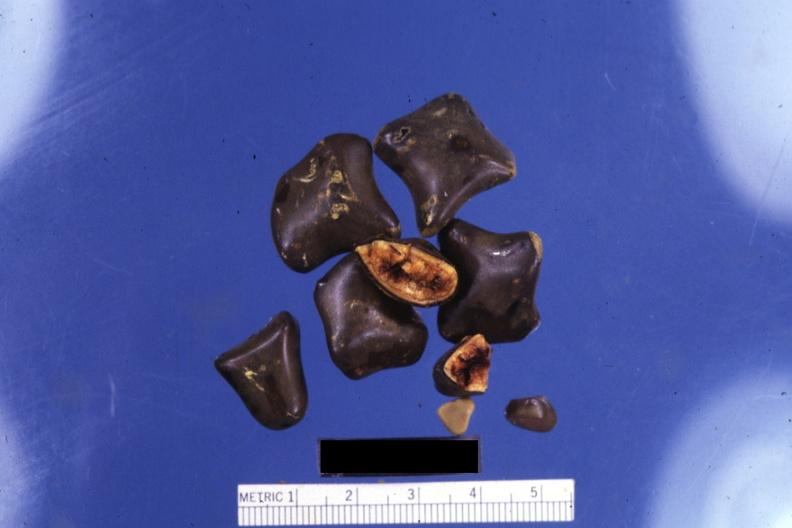s lesion of myocytolysis present?
Answer the question using a single word or phrase. No 